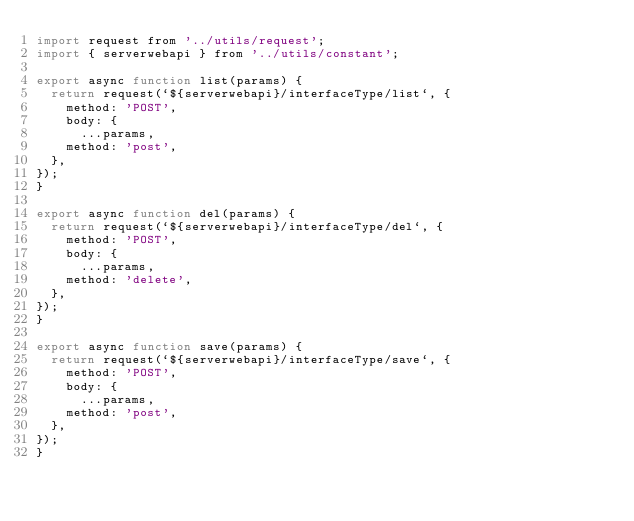<code> <loc_0><loc_0><loc_500><loc_500><_JavaScript_>import request from '../utils/request';
import { serverwebapi } from '../utils/constant';

export async function list(params) {
  return request(`${serverwebapi}/interfaceType/list`, {
    method: 'POST',
    body: {
      ...params,
    method: 'post',
  },
});
}

export async function del(params) {
  return request(`${serverwebapi}/interfaceType/del`, {
    method: 'POST',
    body: {
      ...params,
    method: 'delete',
  },
});
}

export async function save(params) {
  return request(`${serverwebapi}/interfaceType/save`, {
    method: 'POST',
    body: {
      ...params,
    method: 'post',
  },
});
}
</code> 